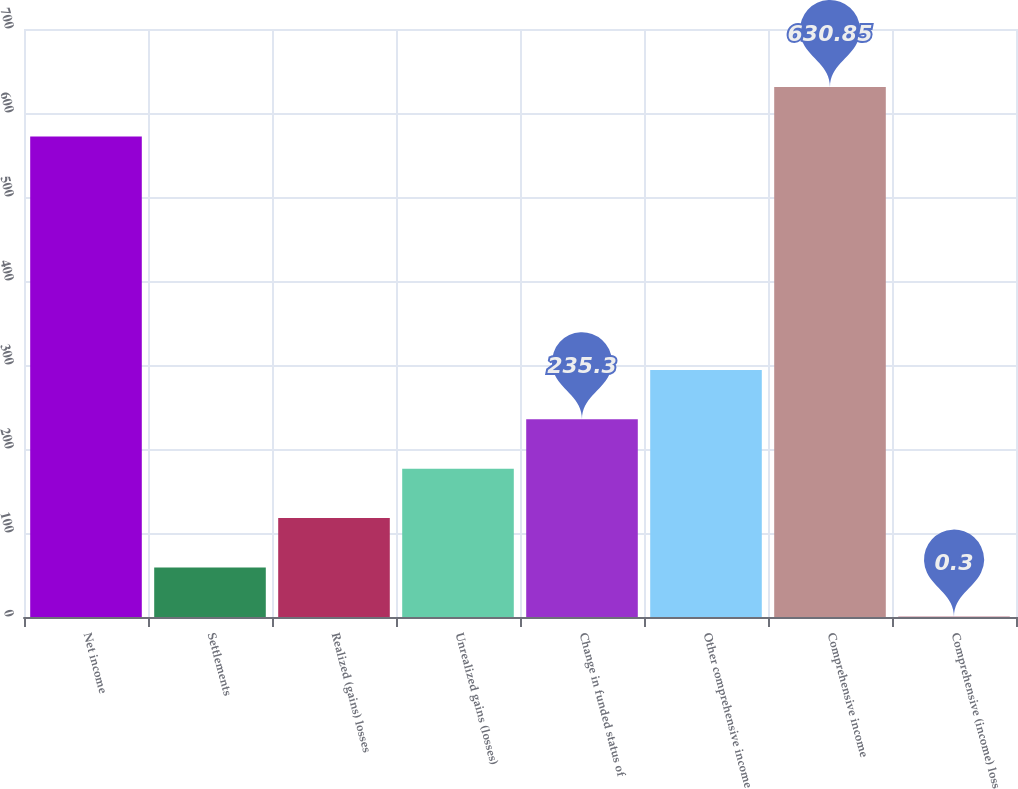<chart> <loc_0><loc_0><loc_500><loc_500><bar_chart><fcel>Net income<fcel>Settlements<fcel>Realized (gains) losses<fcel>Unrealized gains (losses)<fcel>Change in funded status of<fcel>Other comprehensive income<fcel>Comprehensive income<fcel>Comprehensive (income) loss<nl><fcel>572.1<fcel>59.05<fcel>117.8<fcel>176.55<fcel>235.3<fcel>294.05<fcel>630.85<fcel>0.3<nl></chart> 